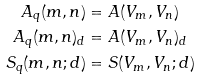<formula> <loc_0><loc_0><loc_500><loc_500>A _ { q } ( m , n ) & = A ( V _ { m } , V _ { n } ) \\ A _ { q } ( m , n ) _ { d } & = A ( V _ { m } , V _ { n } ) _ { d } \\ S _ { q } ( m , n ; d ) & = S ( V _ { m } , V _ { n } ; d )</formula> 